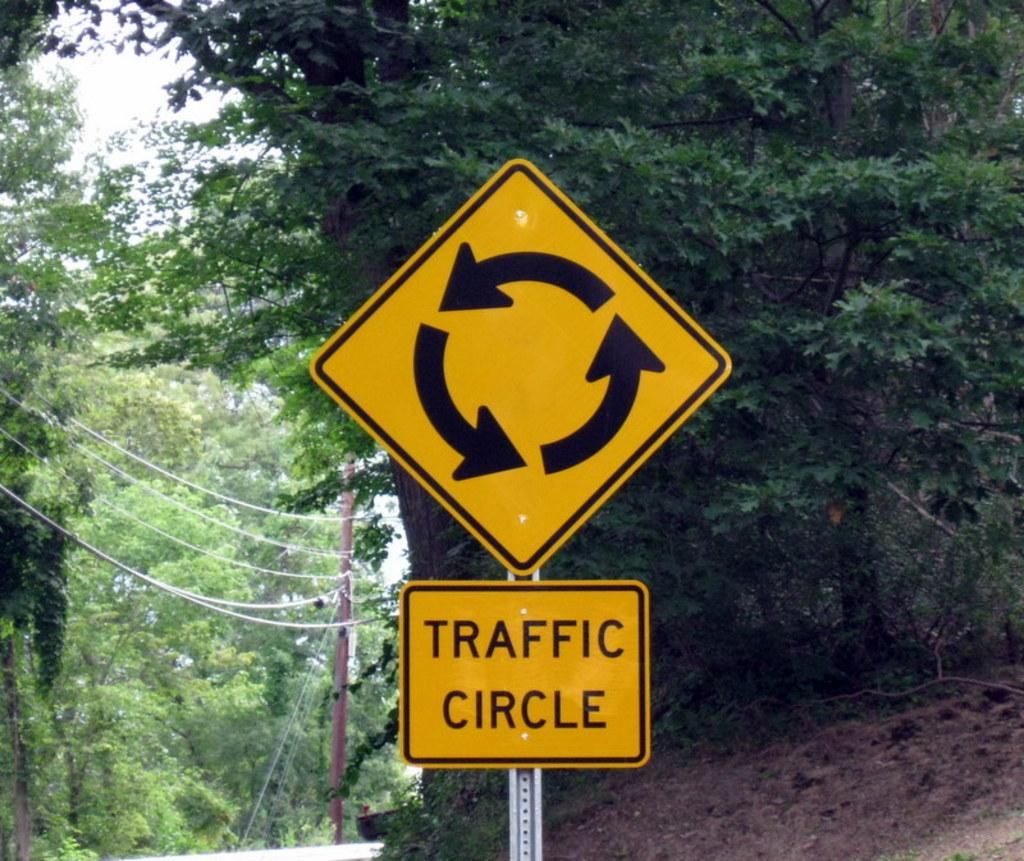<image>
Render a clear and concise summary of the photo. A yellow sign in a wooded area warns of a traffic circle. 